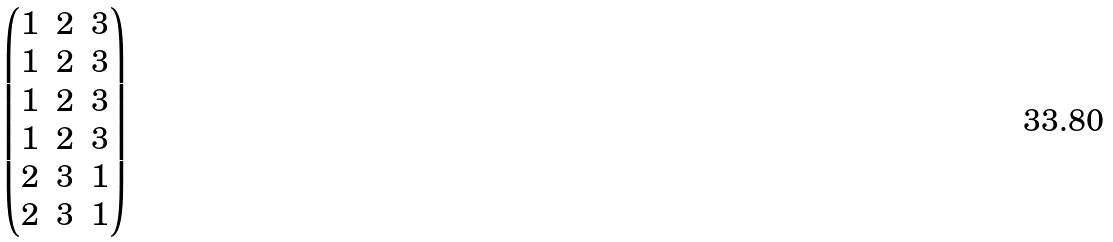<formula> <loc_0><loc_0><loc_500><loc_500>\begin{pmatrix} 1 & 2 & 3 \\ 1 & 2 & 3 \\ 1 & 2 & 3 \\ 1 & 2 & 3 \\ 2 & 3 & 1 \\ 2 & 3 & 1 \end{pmatrix}</formula> 